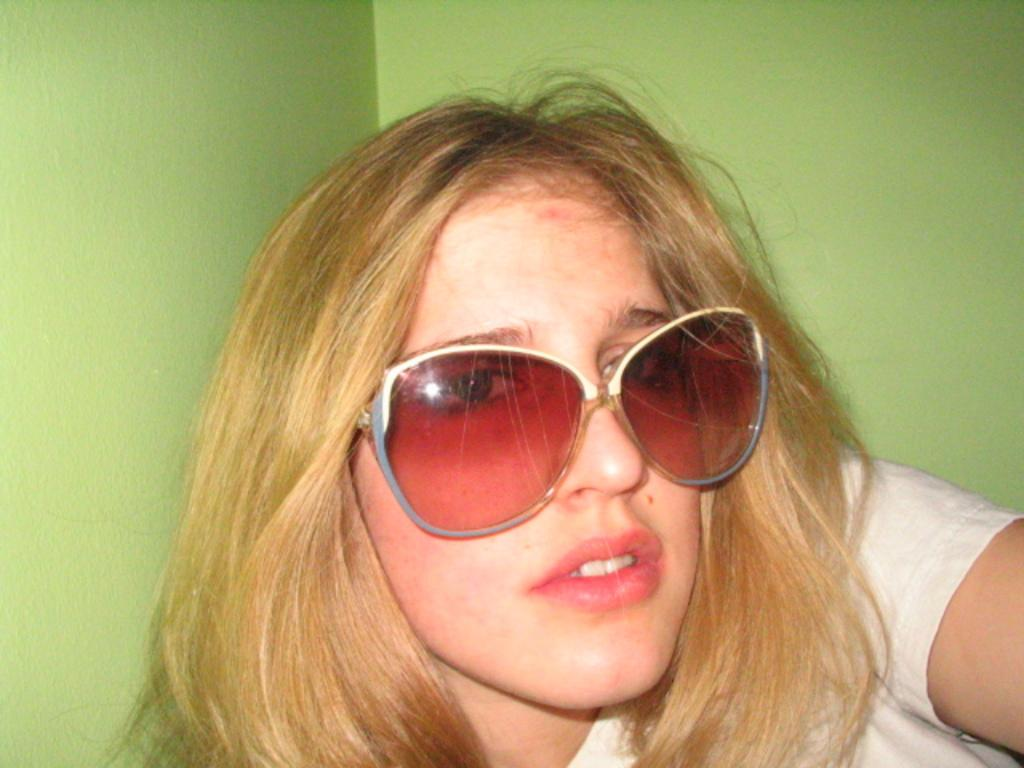What is the main subject of the image? There is a person in the image. Can you describe the position of the person in the image? The person is in front of the image. What can be seen behind the person in the image? There is a wall visible behind the person. What type of spot can be seen on the person's clothing in the image? There is no spot visible on the person's clothing in the image. What type of minister is present in the image? There is no minister present in the image. What type of company is represented by the person in the image? There is no company represented by the person in the image. 